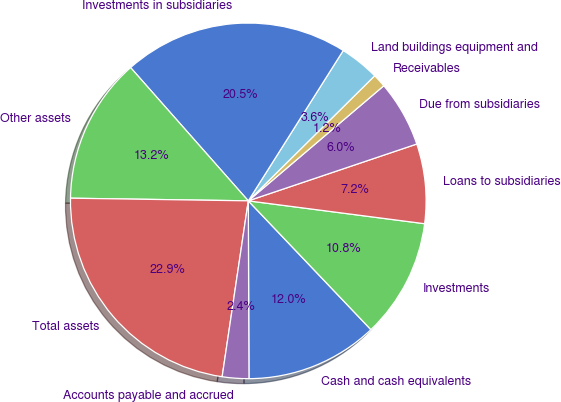Convert chart to OTSL. <chart><loc_0><loc_0><loc_500><loc_500><pie_chart><fcel>Cash and cash equivalents<fcel>Investments<fcel>Loans to subsidiaries<fcel>Due from subsidiaries<fcel>Receivables<fcel>Land buildings equipment and<fcel>Investments in subsidiaries<fcel>Other assets<fcel>Total assets<fcel>Accounts payable and accrued<nl><fcel>12.05%<fcel>10.84%<fcel>7.23%<fcel>6.03%<fcel>1.21%<fcel>3.62%<fcel>20.48%<fcel>13.25%<fcel>22.89%<fcel>2.41%<nl></chart> 